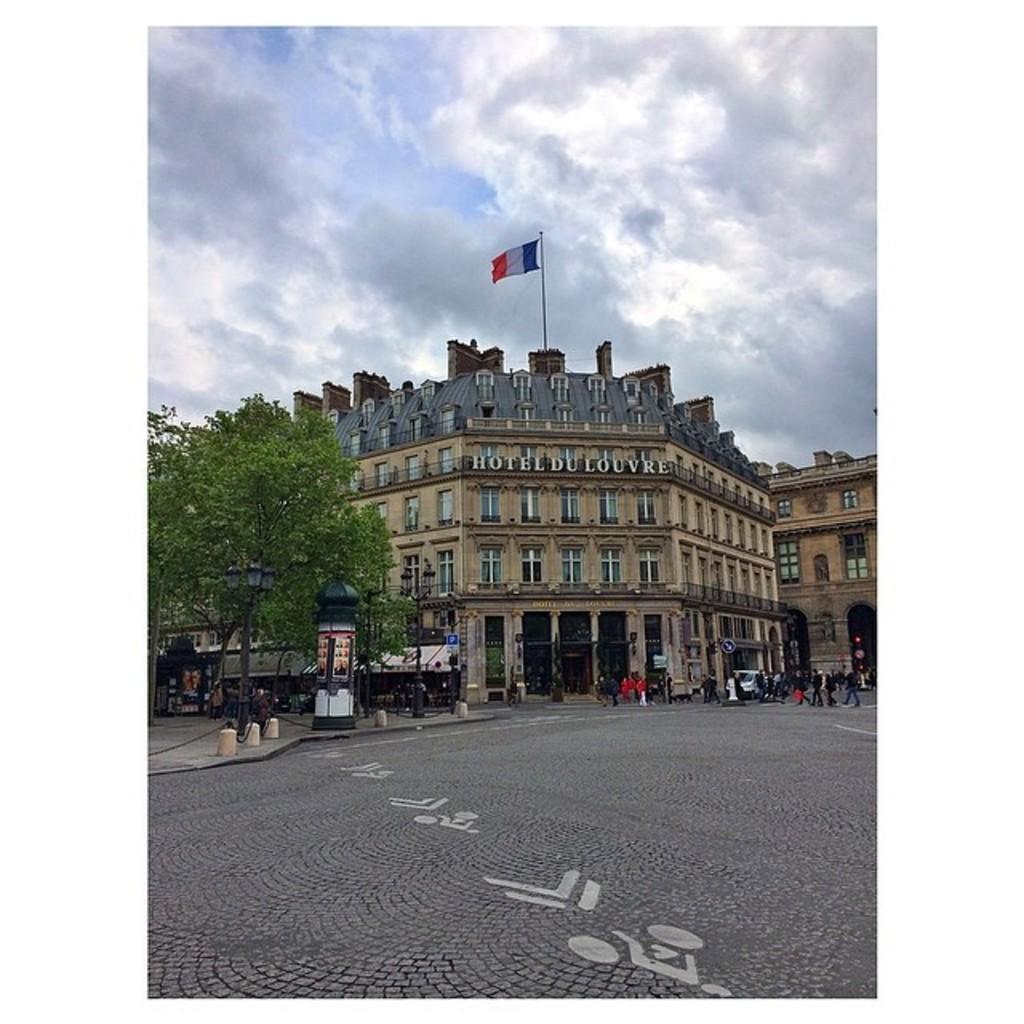In one or two sentences, can you explain what this image depicts? In this image there is the sky towards the top of the image, there are clouds in the sky, there is a building, there is text on the building, there is a pole, there is a flag, there are windows, there is a tree towards the left of the image, there is road towards the bottom of the image, there are persons on the road, there is a vehicle on the road, there is a fencing towards the left of the image. 